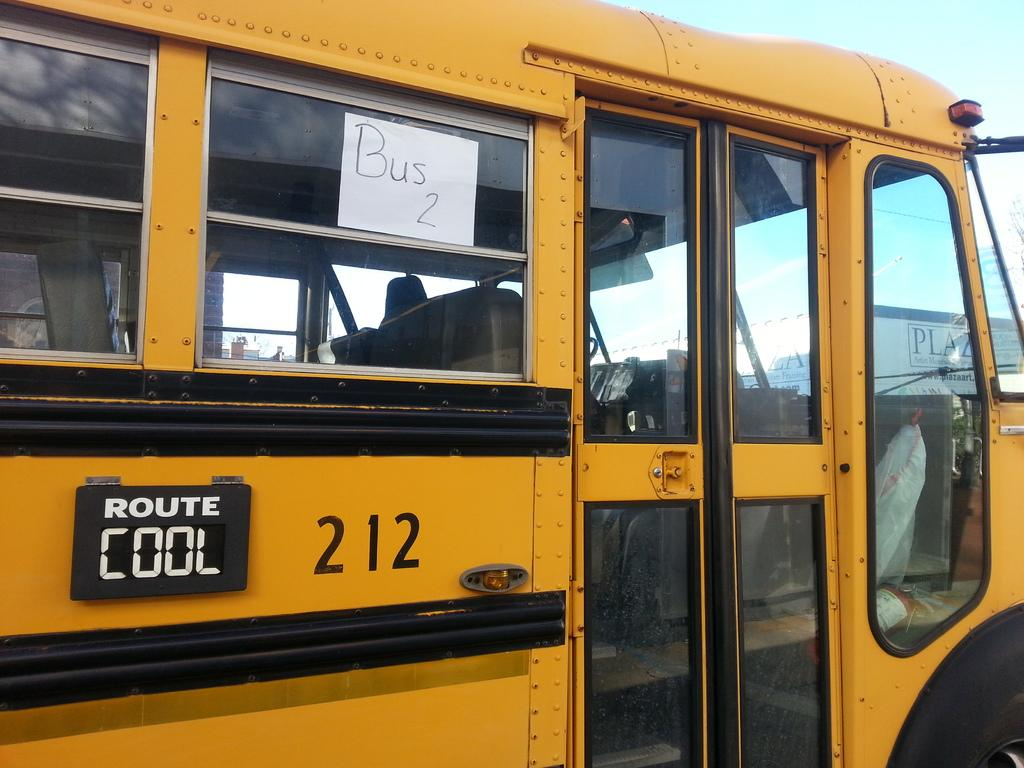<image>
Provide a brief description of the given image. Bus 2 is yellow and going to the Cool route 